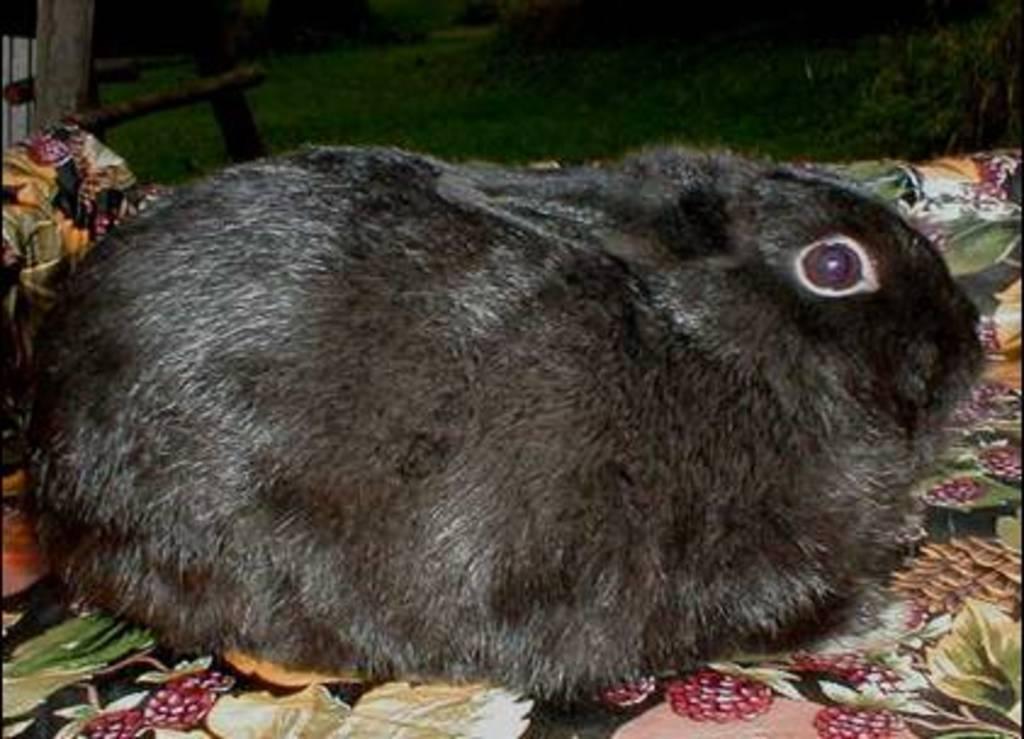Can you describe this image briefly? In this image I can see a black colour rabbit in the front. In the background I can see grass. 